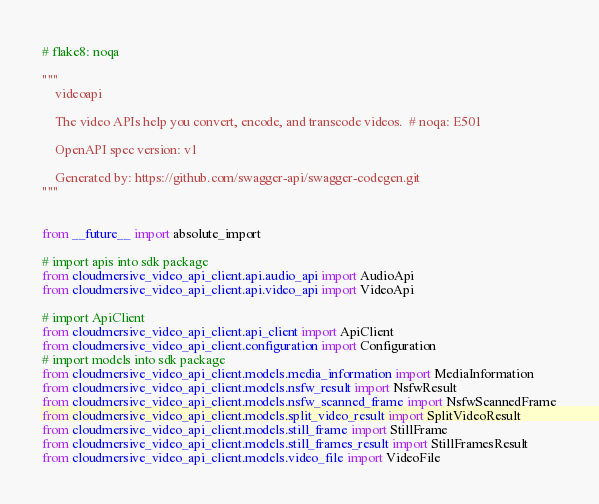Convert code to text. <code><loc_0><loc_0><loc_500><loc_500><_Python_>
# flake8: noqa

"""
    videoapi

    The video APIs help you convert, encode, and transcode videos.  # noqa: E501

    OpenAPI spec version: v1
    
    Generated by: https://github.com/swagger-api/swagger-codegen.git
"""


from __future__ import absolute_import

# import apis into sdk package
from cloudmersive_video_api_client.api.audio_api import AudioApi
from cloudmersive_video_api_client.api.video_api import VideoApi

# import ApiClient
from cloudmersive_video_api_client.api_client import ApiClient
from cloudmersive_video_api_client.configuration import Configuration
# import models into sdk package
from cloudmersive_video_api_client.models.media_information import MediaInformation
from cloudmersive_video_api_client.models.nsfw_result import NsfwResult
from cloudmersive_video_api_client.models.nsfw_scanned_frame import NsfwScannedFrame
from cloudmersive_video_api_client.models.split_video_result import SplitVideoResult
from cloudmersive_video_api_client.models.still_frame import StillFrame
from cloudmersive_video_api_client.models.still_frames_result import StillFramesResult
from cloudmersive_video_api_client.models.video_file import VideoFile
</code> 